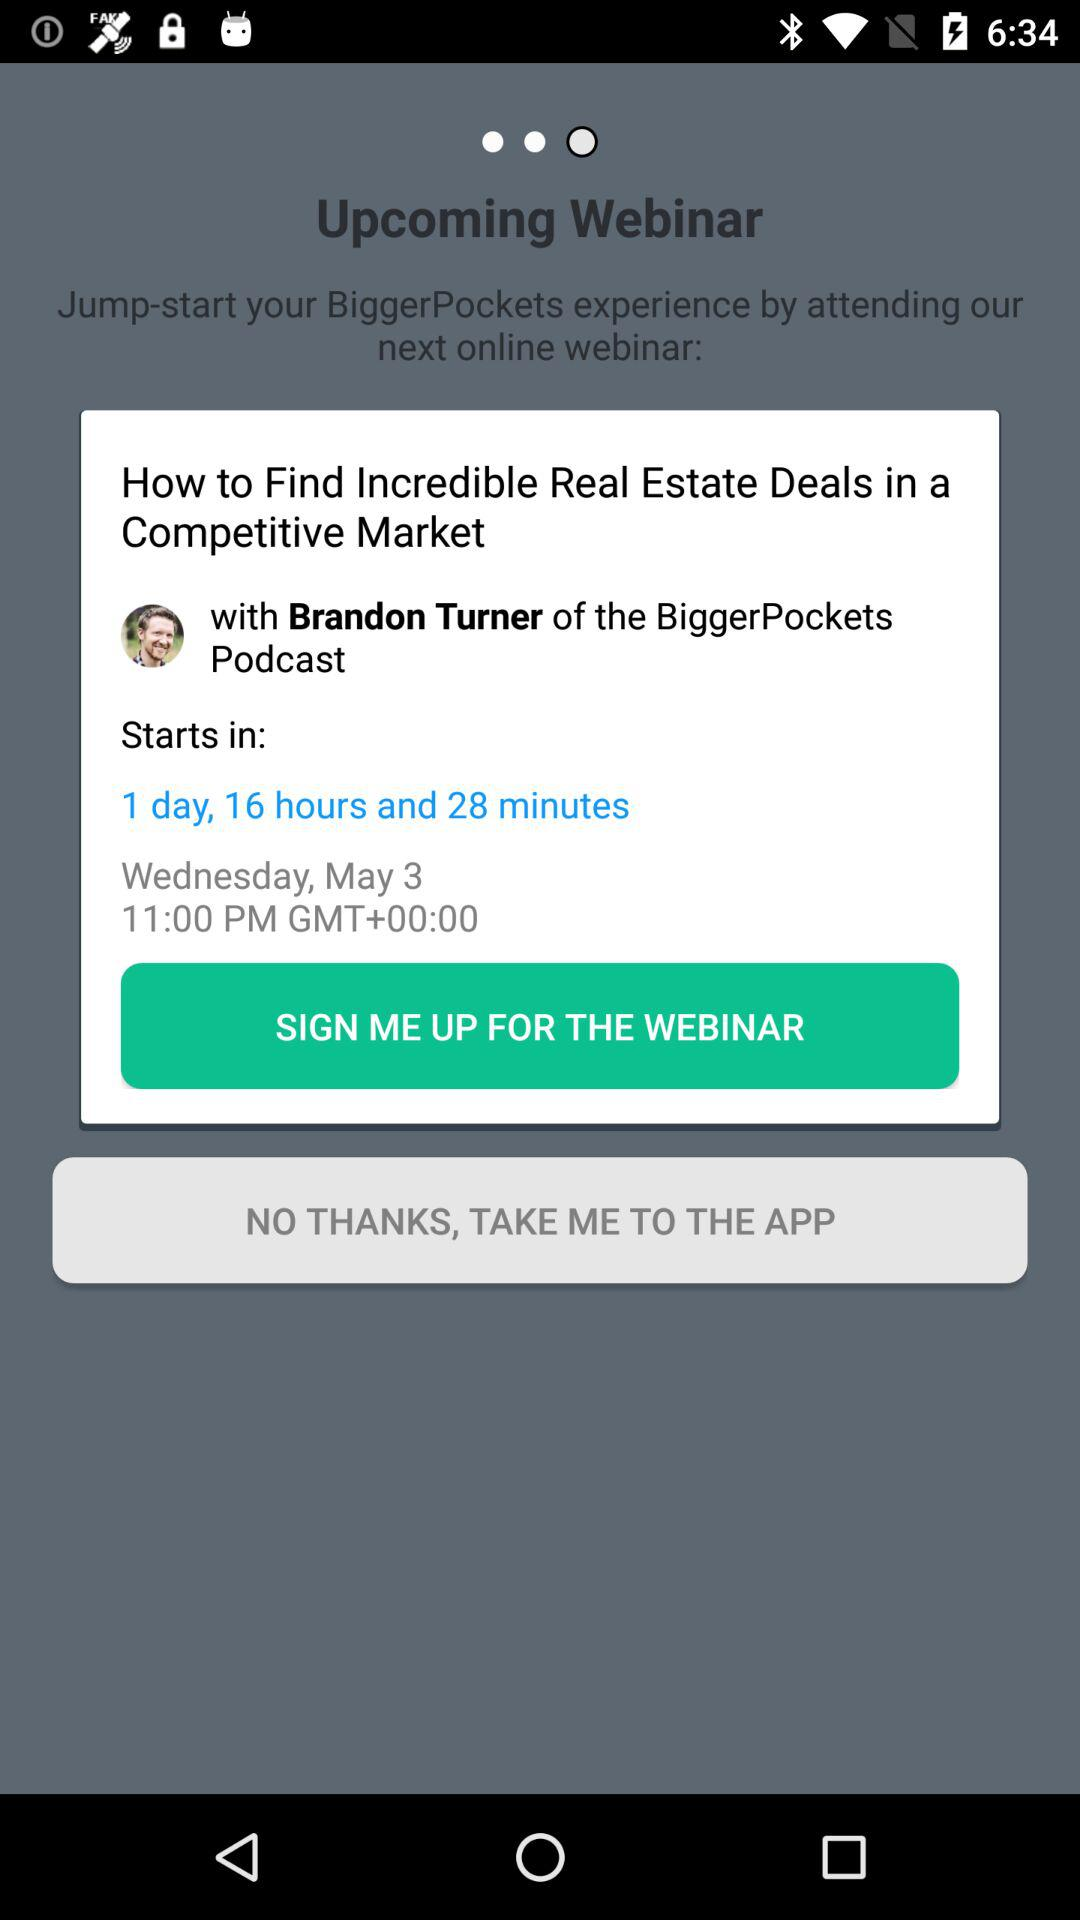Who will host the webinar? The webinar will be hosted by Brandon Turner. 